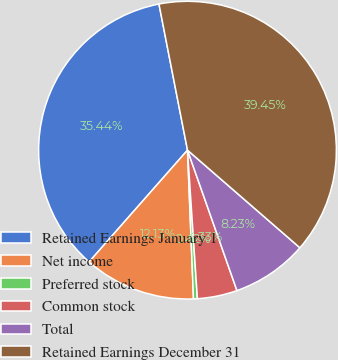Convert chart to OTSL. <chart><loc_0><loc_0><loc_500><loc_500><pie_chart><fcel>Retained Earnings January 1<fcel>Net income<fcel>Preferred stock<fcel>Common stock<fcel>Total<fcel>Retained Earnings December 31<nl><fcel>35.44%<fcel>12.13%<fcel>0.42%<fcel>4.33%<fcel>8.23%<fcel>39.45%<nl></chart> 